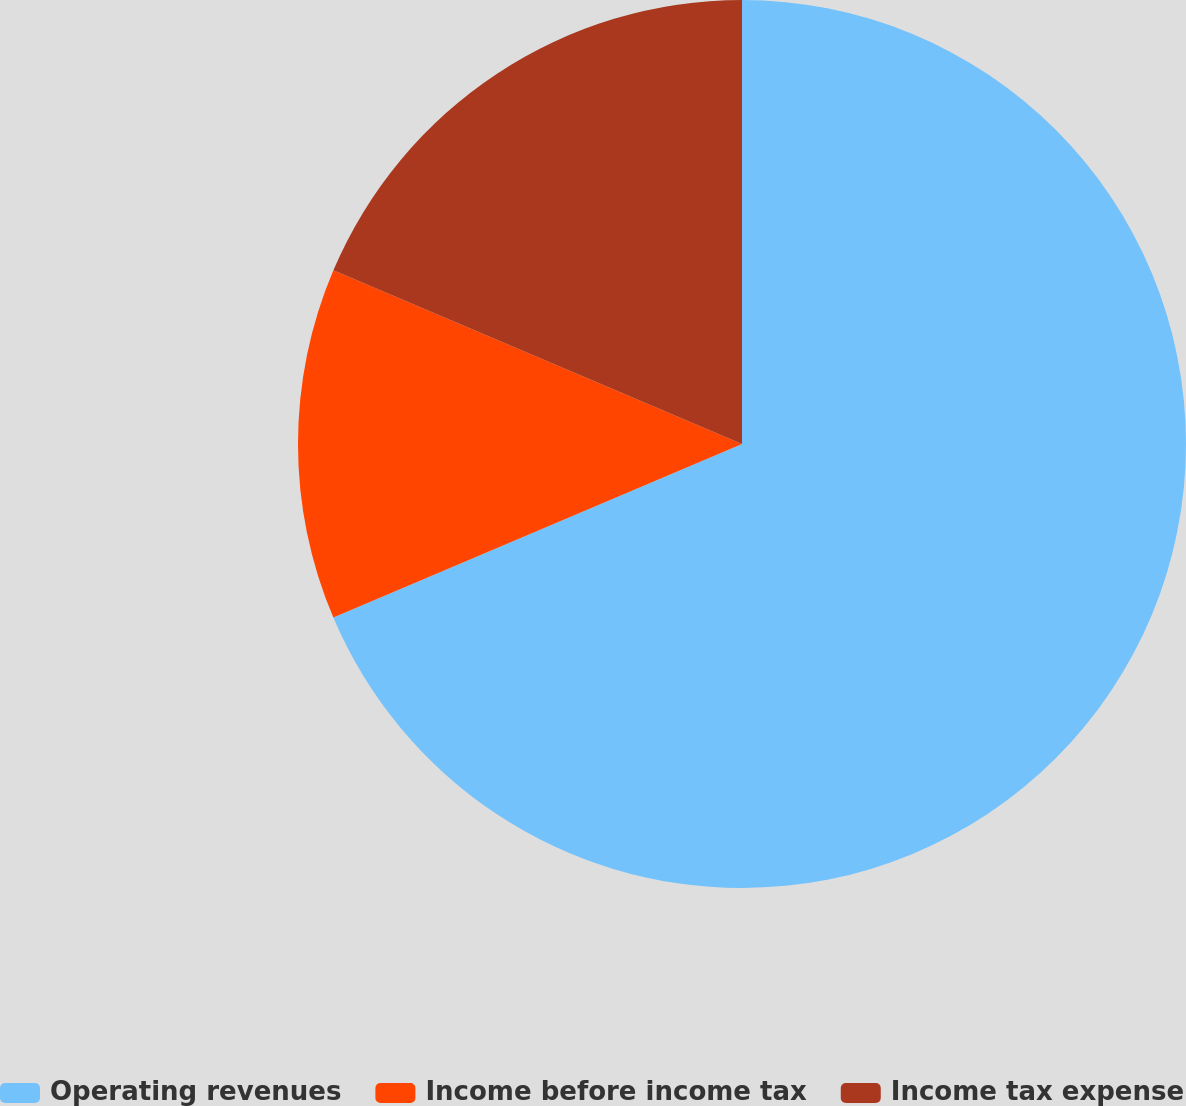Convert chart. <chart><loc_0><loc_0><loc_500><loc_500><pie_chart><fcel>Operating revenues<fcel>Income before income tax<fcel>Income tax expense<nl><fcel>68.6%<fcel>12.79%<fcel>18.6%<nl></chart> 